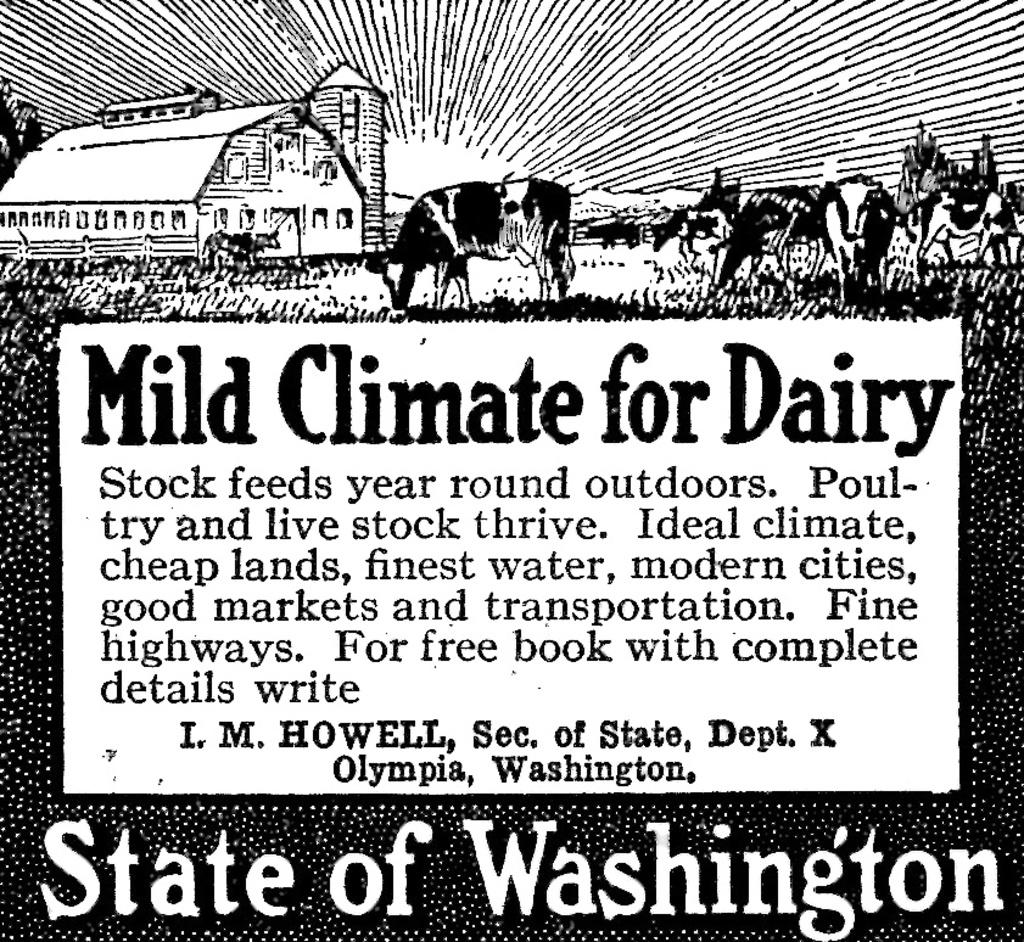What is the main subject of the poster in the image? The poster contains a picture of a house. Are there any other images on the poster besides the house? Yes, the poster contains pictures of animals. Is there any text on the poster? Yes, there is text written on the poster. How many cherries are hanging from the nail on the poster? There are no cherries or nails present on the poster; it features a picture of a house and animals with text. 